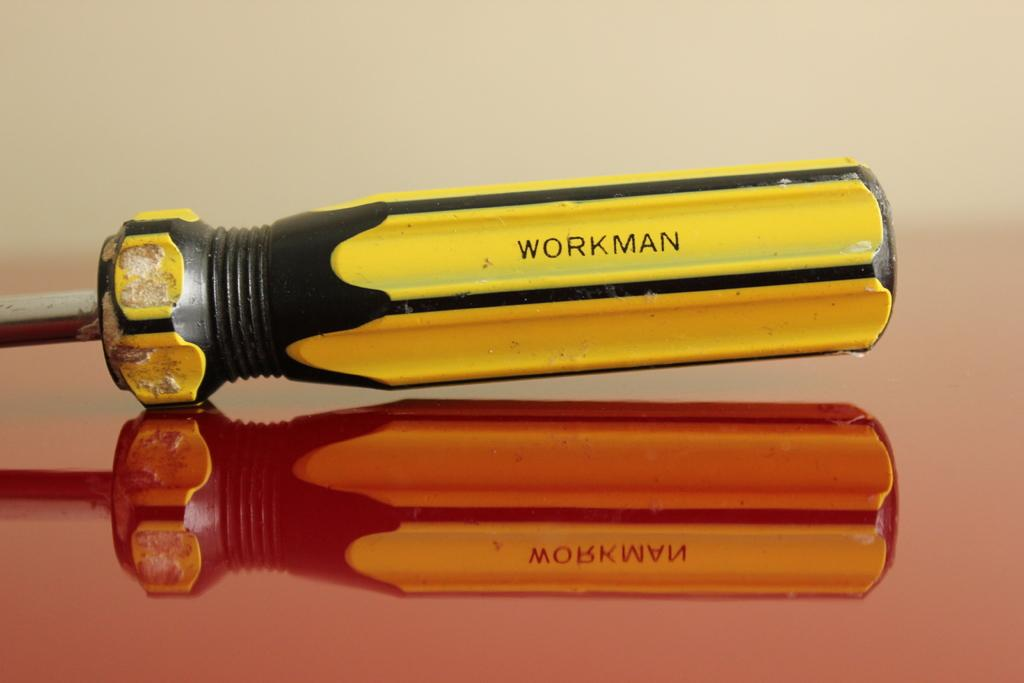What object is placed on the table in the image? There is a screwdriver on a table in the image. Can you describe any additional details about the screwdriver? The screwdriver has a reflection below it in the image. What type of pickle is being sliced on the table in the image? There is no pickle present in the image; it only features a screwdriver on a table. 